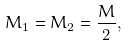<formula> <loc_0><loc_0><loc_500><loc_500>M _ { 1 } = M _ { 2 } = \frac { M } { 2 } ,</formula> 